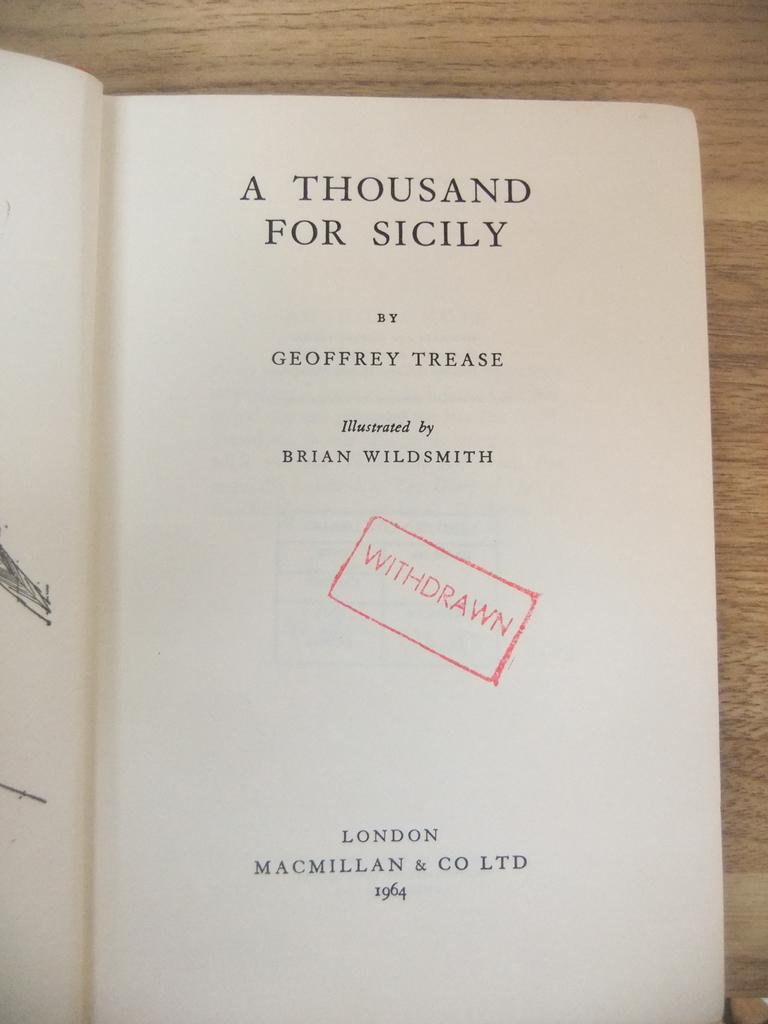<image>
Write a terse but informative summary of the picture. The title of a withdrawn libaray book titled A Thousand For Italy. 